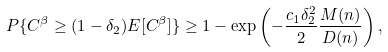<formula> <loc_0><loc_0><loc_500><loc_500>P \{ C ^ { \beta } \geq ( 1 - \delta _ { 2 } ) E [ C ^ { \beta } ] \} \geq 1 - \exp \left ( - \frac { c _ { 1 } \delta _ { 2 } ^ { 2 } } { 2 } \frac { M ( n ) } { D ( n ) } \right ) ,</formula> 